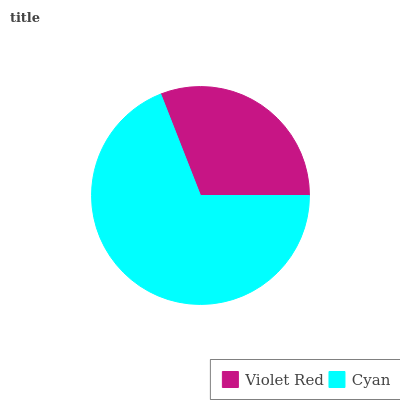Is Violet Red the minimum?
Answer yes or no. Yes. Is Cyan the maximum?
Answer yes or no. Yes. Is Cyan the minimum?
Answer yes or no. No. Is Cyan greater than Violet Red?
Answer yes or no. Yes. Is Violet Red less than Cyan?
Answer yes or no. Yes. Is Violet Red greater than Cyan?
Answer yes or no. No. Is Cyan less than Violet Red?
Answer yes or no. No. Is Cyan the high median?
Answer yes or no. Yes. Is Violet Red the low median?
Answer yes or no. Yes. Is Violet Red the high median?
Answer yes or no. No. Is Cyan the low median?
Answer yes or no. No. 